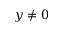Convert formula to latex. <formula><loc_0><loc_0><loc_500><loc_500>y \neq 0</formula> 